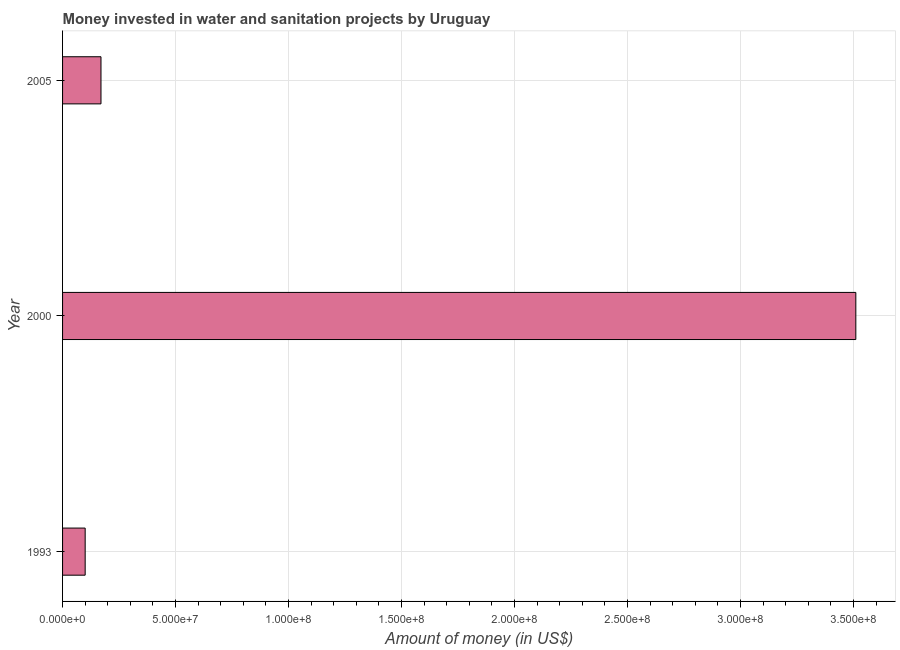Does the graph contain any zero values?
Your response must be concise. No. Does the graph contain grids?
Keep it short and to the point. Yes. What is the title of the graph?
Offer a terse response. Money invested in water and sanitation projects by Uruguay. What is the label or title of the X-axis?
Provide a succinct answer. Amount of money (in US$). What is the label or title of the Y-axis?
Ensure brevity in your answer.  Year. Across all years, what is the maximum investment?
Offer a terse response. 3.51e+08. Across all years, what is the minimum investment?
Your answer should be compact. 1.00e+07. What is the sum of the investment?
Provide a short and direct response. 3.78e+08. What is the difference between the investment in 1993 and 2005?
Your answer should be compact. -7.00e+06. What is the average investment per year?
Your answer should be compact. 1.26e+08. What is the median investment?
Keep it short and to the point. 1.70e+07. In how many years, is the investment greater than 150000000 US$?
Your answer should be compact. 1. Do a majority of the years between 2000 and 2005 (inclusive) have investment greater than 230000000 US$?
Your response must be concise. No. What is the ratio of the investment in 1993 to that in 2005?
Give a very brief answer. 0.59. Is the difference between the investment in 1993 and 2005 greater than the difference between any two years?
Offer a terse response. No. What is the difference between the highest and the second highest investment?
Ensure brevity in your answer.  3.34e+08. What is the difference between the highest and the lowest investment?
Keep it short and to the point. 3.41e+08. In how many years, is the investment greater than the average investment taken over all years?
Your answer should be very brief. 1. How many years are there in the graph?
Your answer should be very brief. 3. What is the Amount of money (in US$) in 2000?
Make the answer very short. 3.51e+08. What is the Amount of money (in US$) of 2005?
Your response must be concise. 1.70e+07. What is the difference between the Amount of money (in US$) in 1993 and 2000?
Offer a very short reply. -3.41e+08. What is the difference between the Amount of money (in US$) in 1993 and 2005?
Ensure brevity in your answer.  -7.00e+06. What is the difference between the Amount of money (in US$) in 2000 and 2005?
Give a very brief answer. 3.34e+08. What is the ratio of the Amount of money (in US$) in 1993 to that in 2000?
Provide a short and direct response. 0.03. What is the ratio of the Amount of money (in US$) in 1993 to that in 2005?
Keep it short and to the point. 0.59. What is the ratio of the Amount of money (in US$) in 2000 to that in 2005?
Provide a short and direct response. 20.65. 